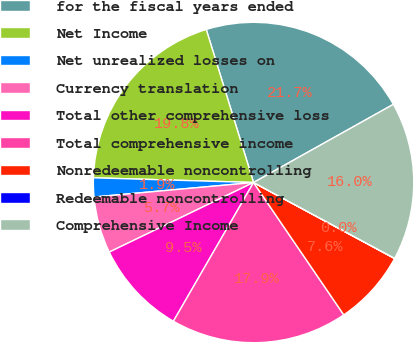Convert chart. <chart><loc_0><loc_0><loc_500><loc_500><pie_chart><fcel>for the fiscal years ended<fcel>Net Income<fcel>Net unrealized losses on<fcel>Currency translation<fcel>Total other comprehensive loss<fcel>Total comprehensive income<fcel>Nonredeemable noncontrolling<fcel>Redeemable noncontrolling<fcel>Comprehensive Income<nl><fcel>21.66%<fcel>19.76%<fcel>1.91%<fcel>5.71%<fcel>9.51%<fcel>17.86%<fcel>7.61%<fcel>0.02%<fcel>15.96%<nl></chart> 